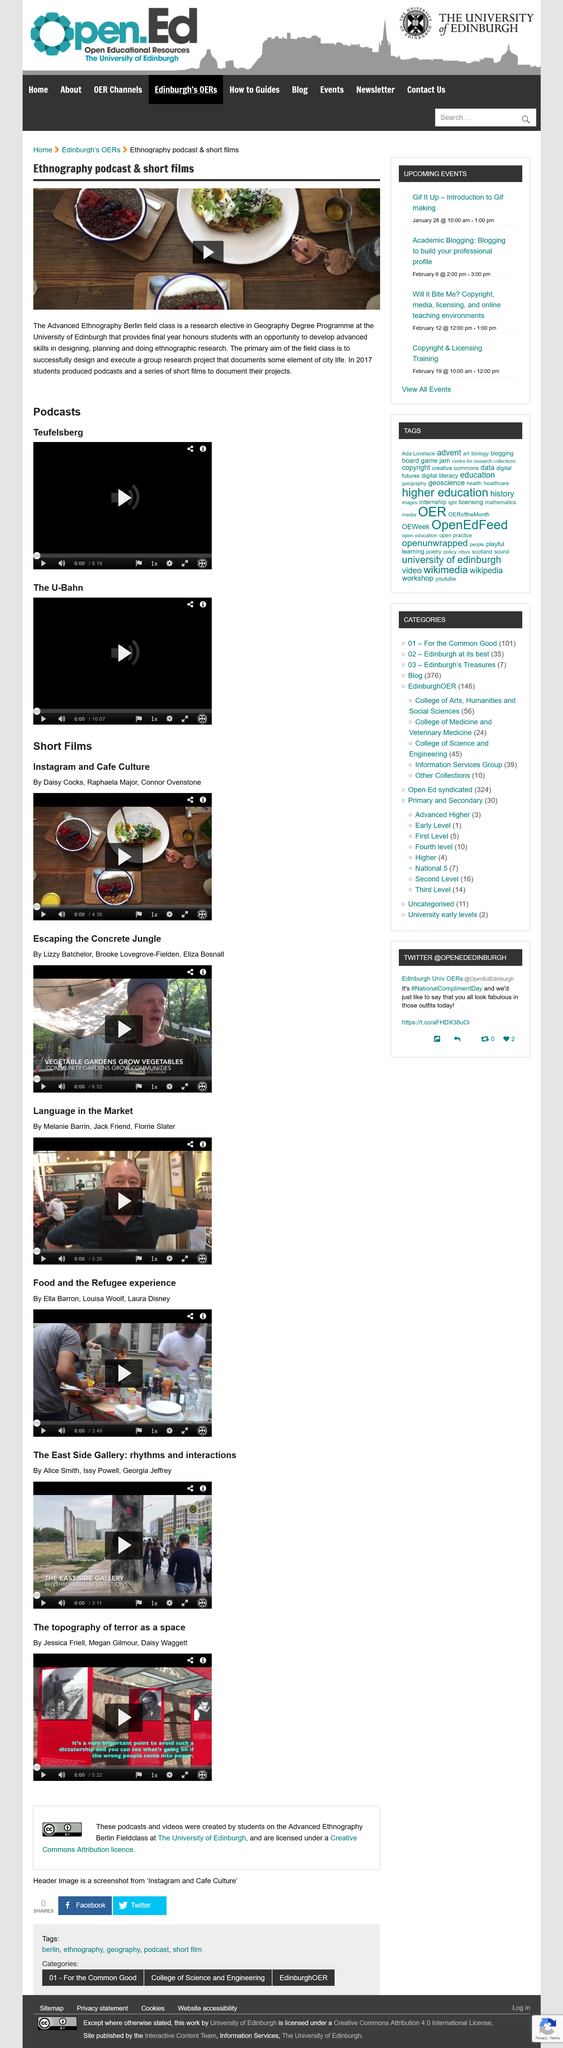Mention a couple of crucial points in this snapshot. In the year 2017, students produced podcasts and a series of short films. The Advanced Ethnography Berlin field class is currently located at the University of Edinburgh. The Advanced Ethnography Berlin field class, as described in the article "Ethnography podcast & short films," is a research elective in the Geography degree program that focuses on ethnographic fieldwork. 